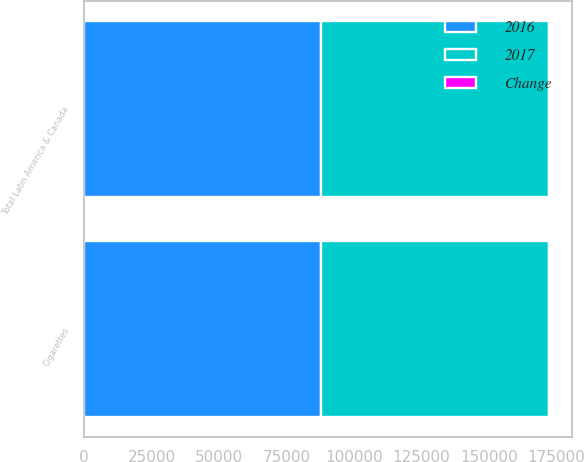Convert chart. <chart><loc_0><loc_0><loc_500><loc_500><stacked_bar_chart><ecel><fcel>Cigarettes<fcel>Total Latin America & Canada<nl><fcel>2017<fcel>84223<fcel>84250<nl><fcel>2016<fcel>87938<fcel>87938<nl><fcel>Change<fcel>4.2<fcel>4.2<nl></chart> 